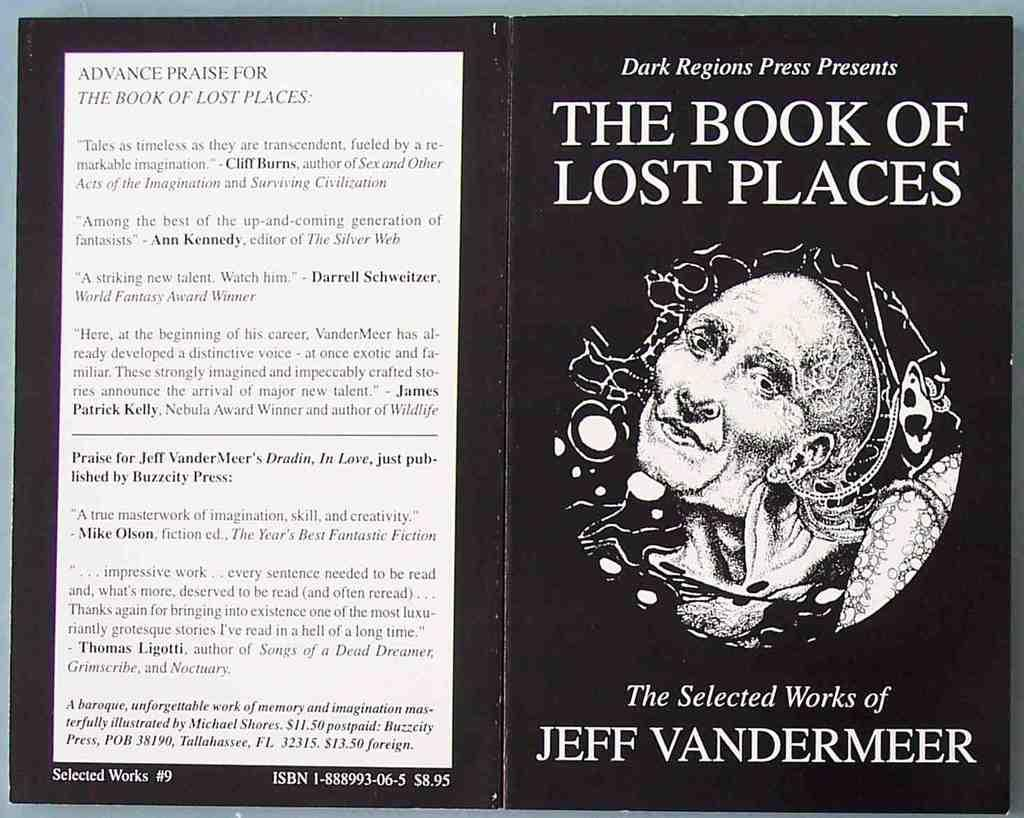Provide a one-sentence caption for the provided image. The front and back covers of The Book of Lost Places is black and white. 